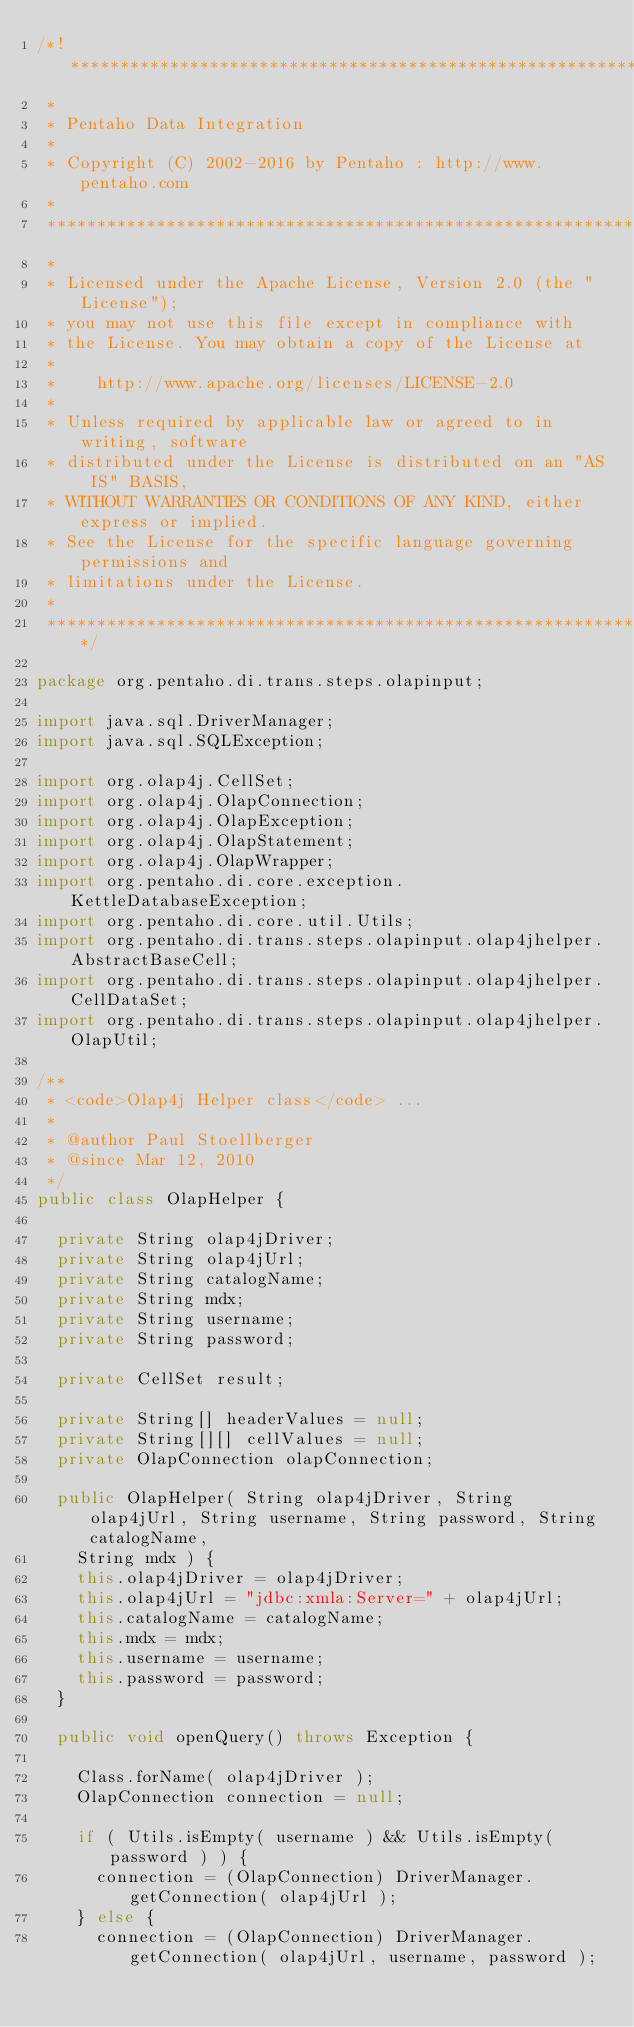<code> <loc_0><loc_0><loc_500><loc_500><_Java_>/*! ******************************************************************************
 *
 * Pentaho Data Integration
 *
 * Copyright (C) 2002-2016 by Pentaho : http://www.pentaho.com
 *
 *******************************************************************************
 *
 * Licensed under the Apache License, Version 2.0 (the "License");
 * you may not use this file except in compliance with
 * the License. You may obtain a copy of the License at
 *
 *    http://www.apache.org/licenses/LICENSE-2.0
 *
 * Unless required by applicable law or agreed to in writing, software
 * distributed under the License is distributed on an "AS IS" BASIS,
 * WITHOUT WARRANTIES OR CONDITIONS OF ANY KIND, either express or implied.
 * See the License for the specific language governing permissions and
 * limitations under the License.
 *
 ******************************************************************************/

package org.pentaho.di.trans.steps.olapinput;

import java.sql.DriverManager;
import java.sql.SQLException;

import org.olap4j.CellSet;
import org.olap4j.OlapConnection;
import org.olap4j.OlapException;
import org.olap4j.OlapStatement;
import org.olap4j.OlapWrapper;
import org.pentaho.di.core.exception.KettleDatabaseException;
import org.pentaho.di.core.util.Utils;
import org.pentaho.di.trans.steps.olapinput.olap4jhelper.AbstractBaseCell;
import org.pentaho.di.trans.steps.olapinput.olap4jhelper.CellDataSet;
import org.pentaho.di.trans.steps.olapinput.olap4jhelper.OlapUtil;

/**
 * <code>Olap4j Helper class</code> ...
 *
 * @author Paul Stoellberger
 * @since Mar 12, 2010
 */
public class OlapHelper {

  private String olap4jDriver;
  private String olap4jUrl;
  private String catalogName;
  private String mdx;
  private String username;
  private String password;

  private CellSet result;

  private String[] headerValues = null;
  private String[][] cellValues = null;
  private OlapConnection olapConnection;

  public OlapHelper( String olap4jDriver, String olap4jUrl, String username, String password, String catalogName,
    String mdx ) {
    this.olap4jDriver = olap4jDriver;
    this.olap4jUrl = "jdbc:xmla:Server=" + olap4jUrl;
    this.catalogName = catalogName;
    this.mdx = mdx;
    this.username = username;
    this.password = password;
  }

  public void openQuery() throws Exception {

    Class.forName( olap4jDriver );
    OlapConnection connection = null;

    if ( Utils.isEmpty( username ) && Utils.isEmpty( password ) ) {
      connection = (OlapConnection) DriverManager.getConnection( olap4jUrl );
    } else {
      connection = (OlapConnection) DriverManager.getConnection( olap4jUrl, username, password );</code> 